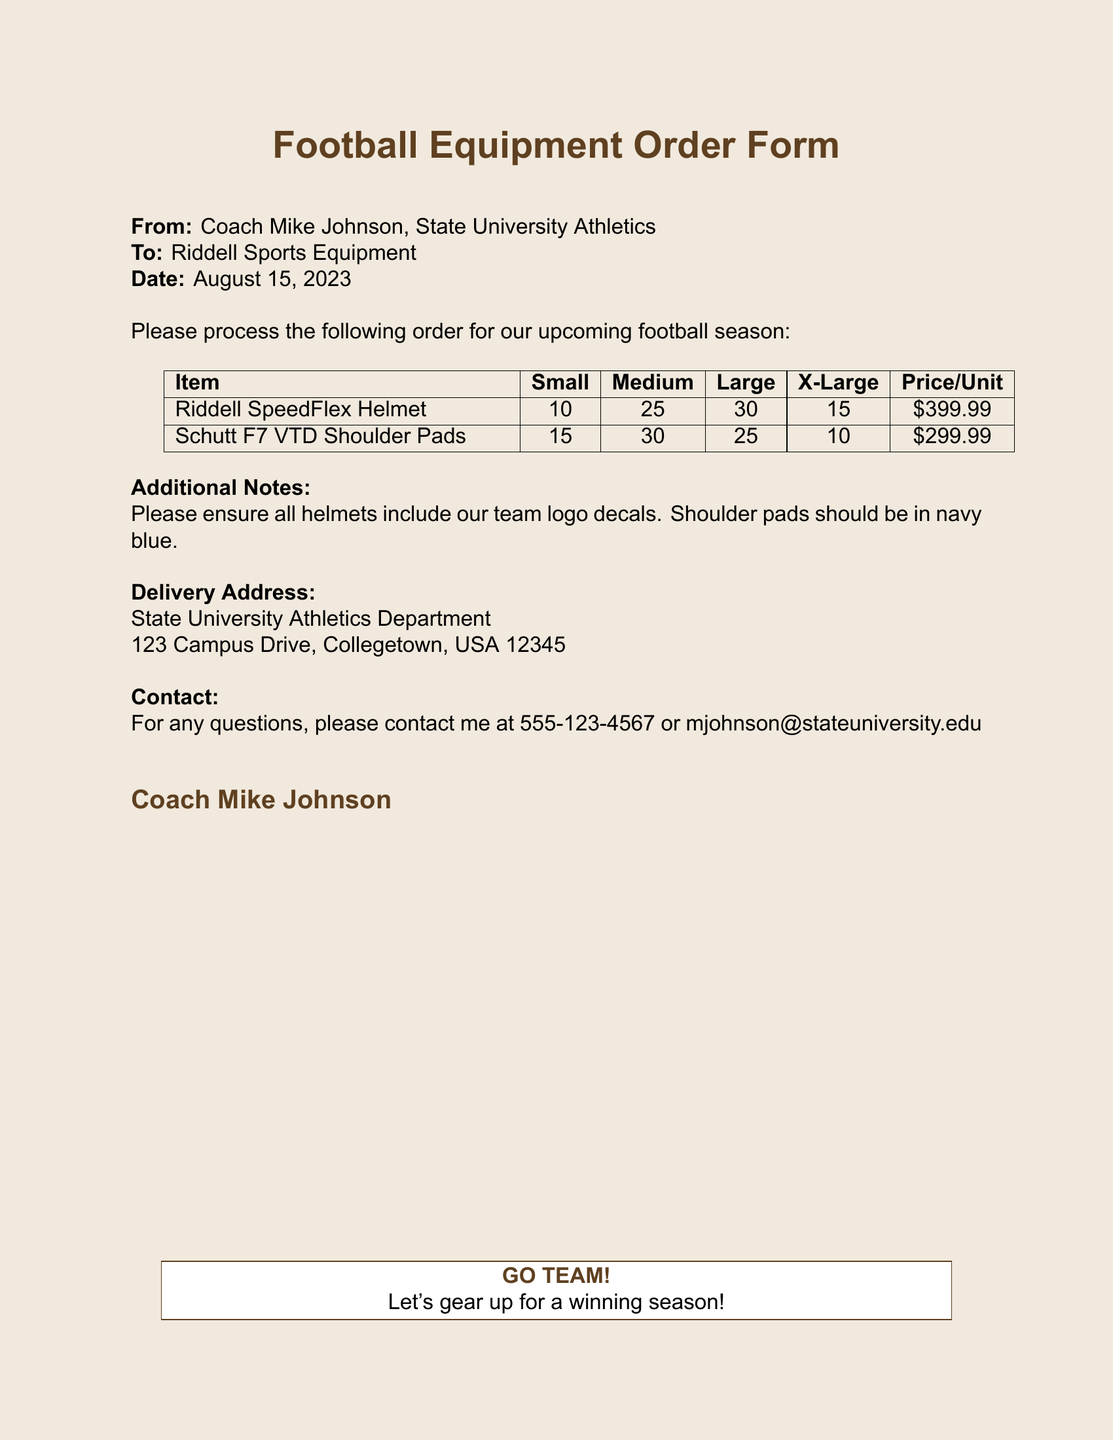what is the date of the order? The document specifies the date when the order is to be processed as August 15, 2023.
Answer: August 15, 2023 who is the contact person for this order? The contact person listed on the document is Coach Mike Johnson, who is from State University Athletics.
Answer: Coach Mike Johnson how many Riddell SpeedFlex Helmets are being ordered in Large size? The order indicates that 30 Riddell SpeedFlex Helmets are requested in the Large size.
Answer: 30 what color should the shoulder pads be? The document states that the shoulder pads should be in navy blue.
Answer: navy blue what is the price per unit for Schutt F7 VTD Shoulder Pads? Each Schutt F7 VTD Shoulder Pad is priced at $299.99 according to the order form.
Answer: $299.99 which item has the highest quantity order? The item with the highest quantity ordered is the Riddell SpeedFlex Helmet, with a total of 80 units across all sizes.
Answer: Riddell SpeedFlex Helmet what is the delivery address? The delivery address specified in the document is the State University Athletics Department located at 123 Campus Drive, Collegetown, USA 12345.
Answer: 123 Campus Drive, Collegetown, USA 12345 how many shoulder pads are ordered in Small size? The document indicates that 15 Schutt F7 VTD Shoulder Pads in Small size are being ordered.
Answer: 15 